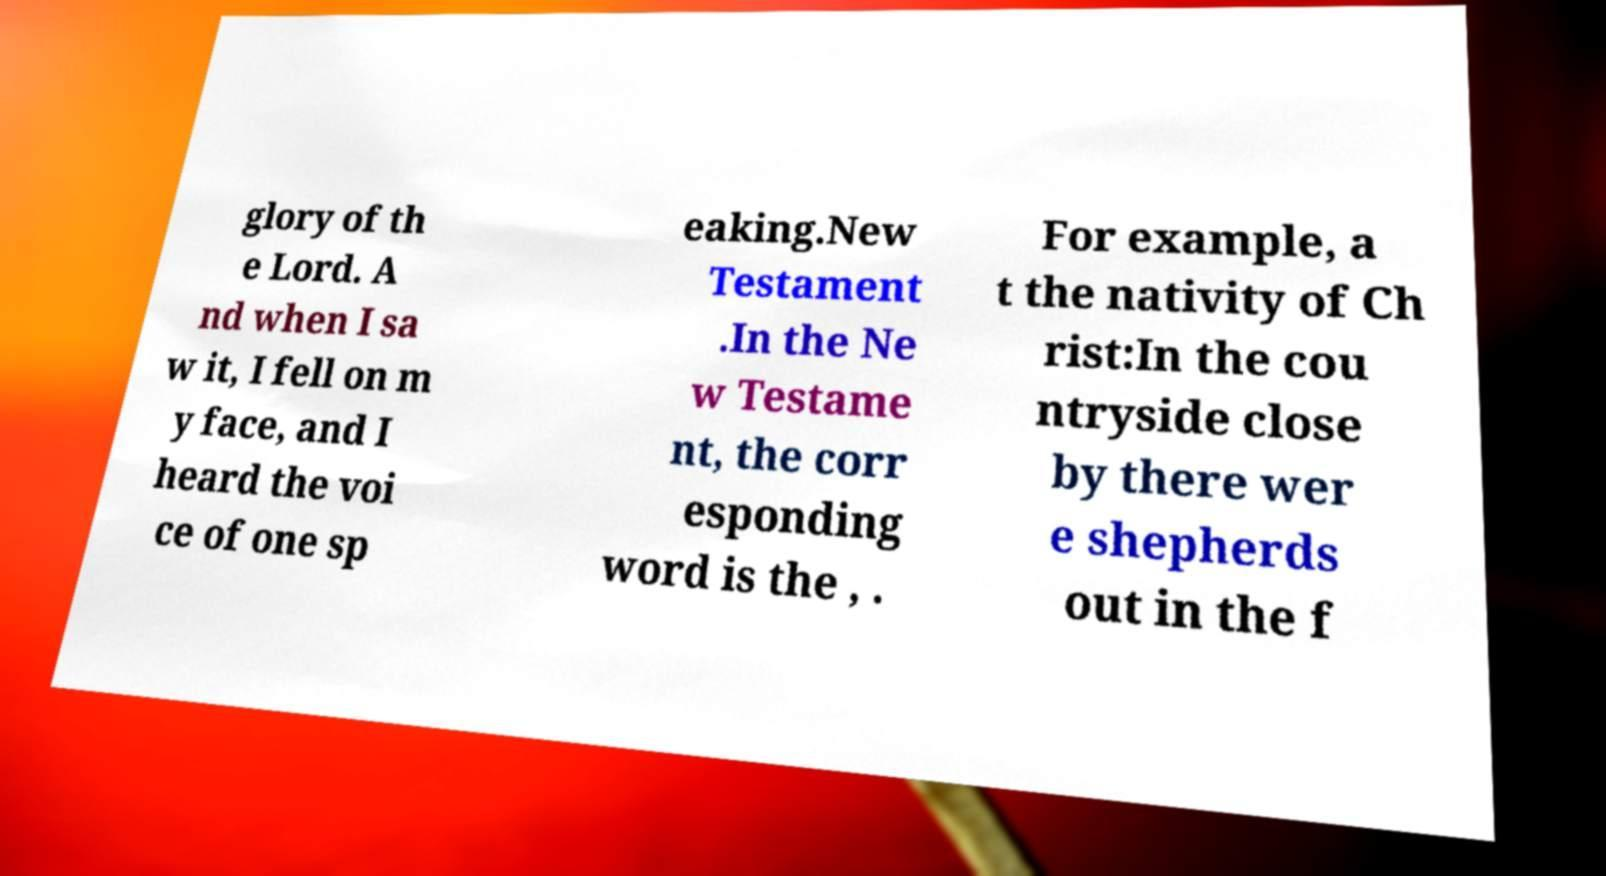I need the written content from this picture converted into text. Can you do that? glory of th e Lord. A nd when I sa w it, I fell on m y face, and I heard the voi ce of one sp eaking.New Testament .In the Ne w Testame nt, the corr esponding word is the , . For example, a t the nativity of Ch rist:In the cou ntryside close by there wer e shepherds out in the f 